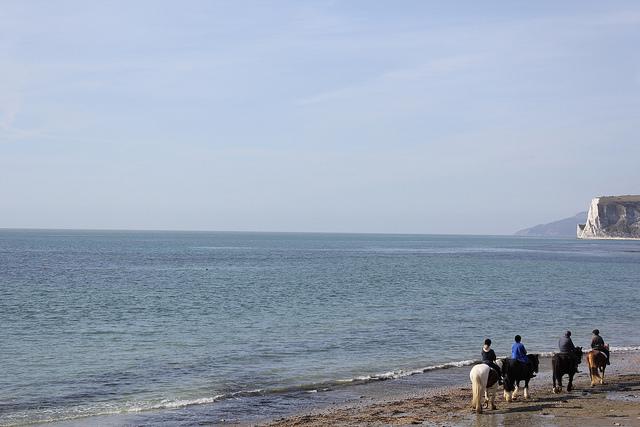Is it a cloudy day?
Quick response, please. No. Are these horses walking or galloping?
Quick response, please. Walking. How many people in picture?
Quick response, please. 4. What might be keeping them out of the water?
Give a very brief answer. Horses. Which animals are these?
Write a very short answer. Horses. Is it low or high tide?
Answer briefly. Low. What is in the bottom right corner?
Short answer required. People on horses. How many horses are white?
Concise answer only. 1. Is the sun setting?
Keep it brief. No. 